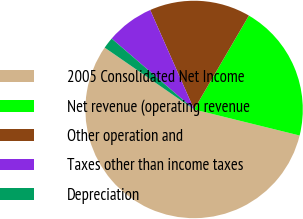Convert chart to OTSL. <chart><loc_0><loc_0><loc_500><loc_500><pie_chart><fcel>2005 Consolidated Net Income<fcel>Net revenue (operating revenue<fcel>Other operation and<fcel>Taxes other than income taxes<fcel>Depreciation<nl><fcel>55.78%<fcel>20.44%<fcel>15.03%<fcel>7.08%<fcel>1.67%<nl></chart> 